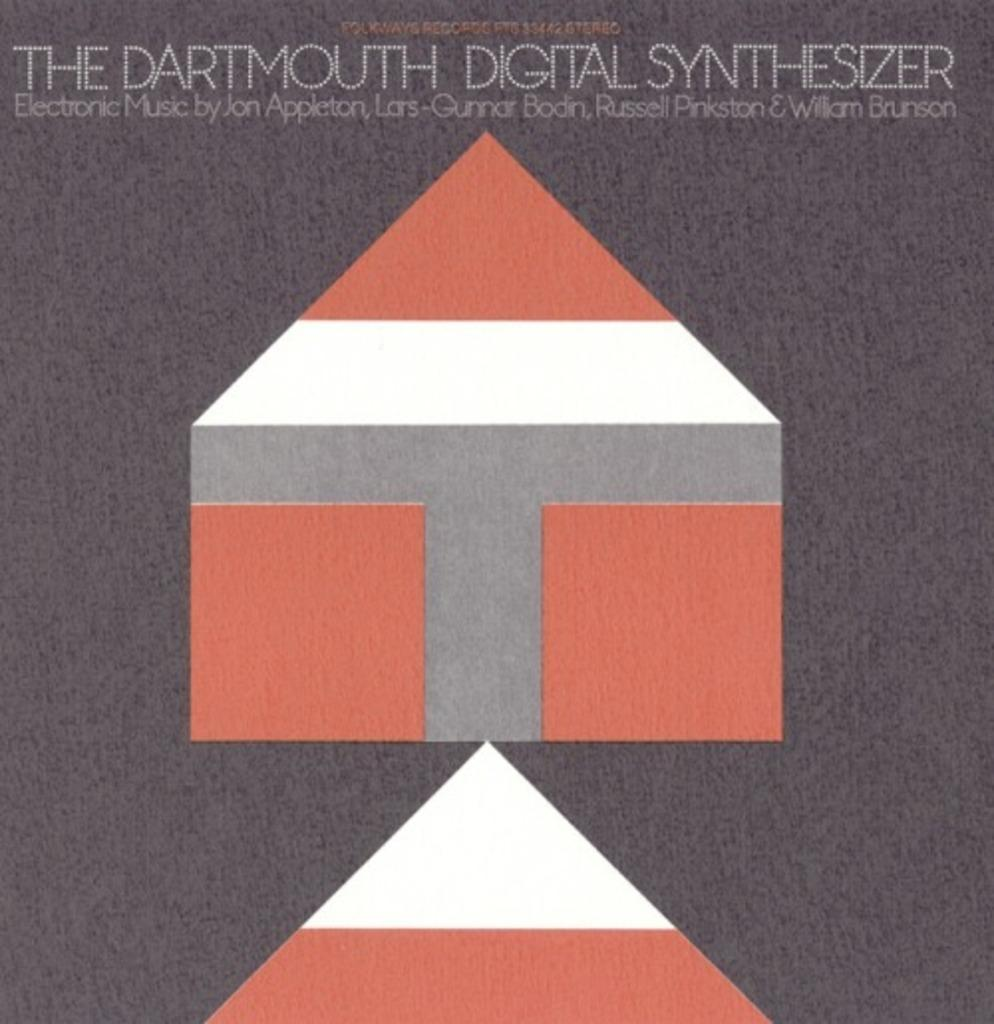<image>
Summarize the visual content of the image. an album cover from the dartmouth digital synthesizer 